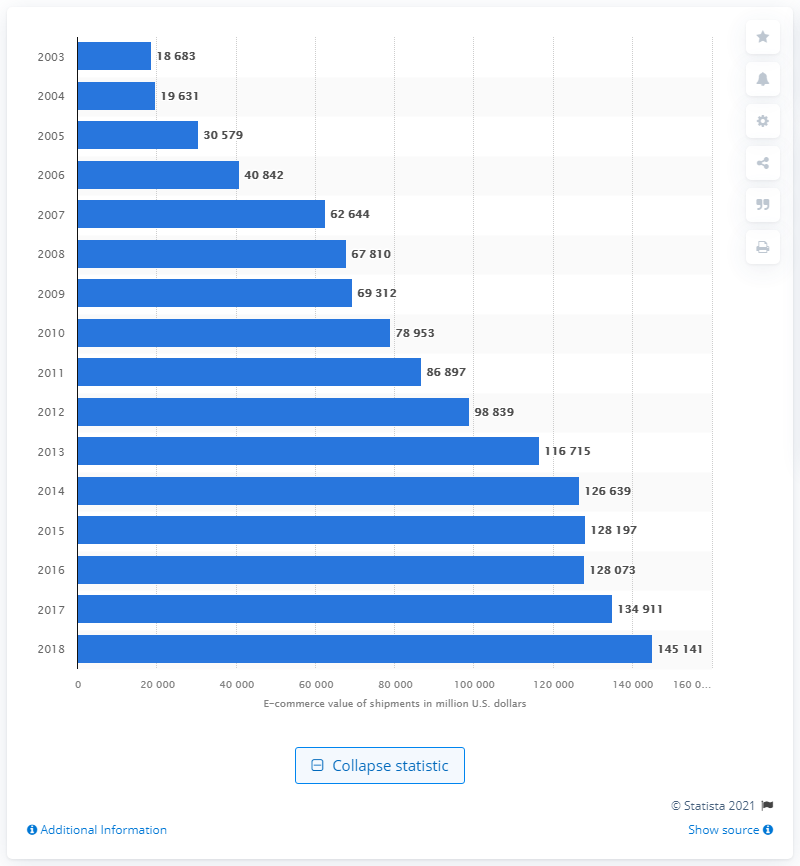Draw attention to some important aspects in this diagram. The value of B2B e-commerce shipments in the paper manufacturing industry during the previous measured period was 134,911. In 2018, the value of B2B e-commerce shipments in the paper manufacturing industry in the United States was approximately 145,141. 